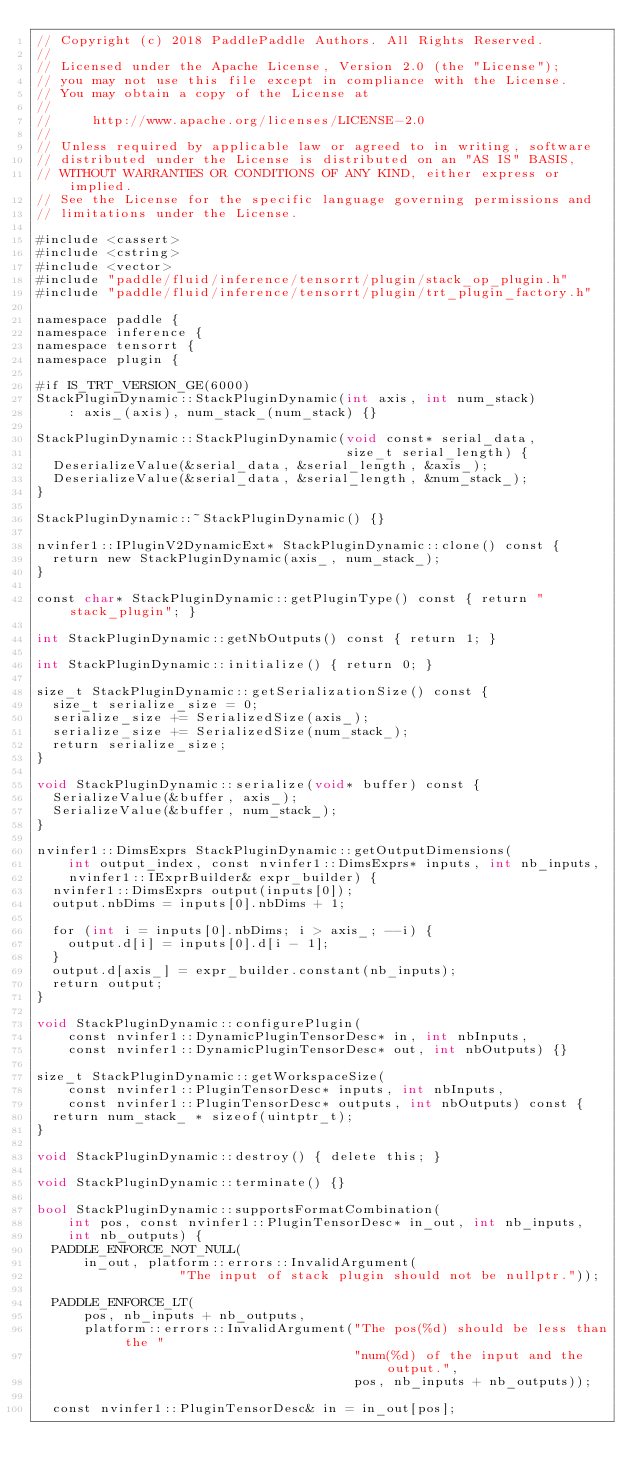Convert code to text. <code><loc_0><loc_0><loc_500><loc_500><_Cuda_>// Copyright (c) 2018 PaddlePaddle Authors. All Rights Reserved.
//
// Licensed under the Apache License, Version 2.0 (the "License");
// you may not use this file except in compliance with the License.
// You may obtain a copy of the License at
//
//     http://www.apache.org/licenses/LICENSE-2.0
//
// Unless required by applicable law or agreed to in writing, software
// distributed under the License is distributed on an "AS IS" BASIS,
// WITHOUT WARRANTIES OR CONDITIONS OF ANY KIND, either express or implied.
// See the License for the specific language governing permissions and
// limitations under the License.

#include <cassert>
#include <cstring>
#include <vector>
#include "paddle/fluid/inference/tensorrt/plugin/stack_op_plugin.h"
#include "paddle/fluid/inference/tensorrt/plugin/trt_plugin_factory.h"

namespace paddle {
namespace inference {
namespace tensorrt {
namespace plugin {

#if IS_TRT_VERSION_GE(6000)
StackPluginDynamic::StackPluginDynamic(int axis, int num_stack)
    : axis_(axis), num_stack_(num_stack) {}

StackPluginDynamic::StackPluginDynamic(void const* serial_data,
                                       size_t serial_length) {
  DeserializeValue(&serial_data, &serial_length, &axis_);
  DeserializeValue(&serial_data, &serial_length, &num_stack_);
}

StackPluginDynamic::~StackPluginDynamic() {}

nvinfer1::IPluginV2DynamicExt* StackPluginDynamic::clone() const {
  return new StackPluginDynamic(axis_, num_stack_);
}

const char* StackPluginDynamic::getPluginType() const { return "stack_plugin"; }

int StackPluginDynamic::getNbOutputs() const { return 1; }

int StackPluginDynamic::initialize() { return 0; }

size_t StackPluginDynamic::getSerializationSize() const {
  size_t serialize_size = 0;
  serialize_size += SerializedSize(axis_);
  serialize_size += SerializedSize(num_stack_);
  return serialize_size;
}

void StackPluginDynamic::serialize(void* buffer) const {
  SerializeValue(&buffer, axis_);
  SerializeValue(&buffer, num_stack_);
}

nvinfer1::DimsExprs StackPluginDynamic::getOutputDimensions(
    int output_index, const nvinfer1::DimsExprs* inputs, int nb_inputs,
    nvinfer1::IExprBuilder& expr_builder) {
  nvinfer1::DimsExprs output(inputs[0]);
  output.nbDims = inputs[0].nbDims + 1;

  for (int i = inputs[0].nbDims; i > axis_; --i) {
    output.d[i] = inputs[0].d[i - 1];
  }
  output.d[axis_] = expr_builder.constant(nb_inputs);
  return output;
}

void StackPluginDynamic::configurePlugin(
    const nvinfer1::DynamicPluginTensorDesc* in, int nbInputs,
    const nvinfer1::DynamicPluginTensorDesc* out, int nbOutputs) {}

size_t StackPluginDynamic::getWorkspaceSize(
    const nvinfer1::PluginTensorDesc* inputs, int nbInputs,
    const nvinfer1::PluginTensorDesc* outputs, int nbOutputs) const {
  return num_stack_ * sizeof(uintptr_t);
}

void StackPluginDynamic::destroy() { delete this; }

void StackPluginDynamic::terminate() {}

bool StackPluginDynamic::supportsFormatCombination(
    int pos, const nvinfer1::PluginTensorDesc* in_out, int nb_inputs,
    int nb_outputs) {
  PADDLE_ENFORCE_NOT_NULL(
      in_out, platform::errors::InvalidArgument(
                  "The input of stack plugin should not be nullptr."));

  PADDLE_ENFORCE_LT(
      pos, nb_inputs + nb_outputs,
      platform::errors::InvalidArgument("The pos(%d) should be less than the "
                                        "num(%d) of the input and the output.",
                                        pos, nb_inputs + nb_outputs));

  const nvinfer1::PluginTensorDesc& in = in_out[pos];</code> 